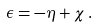<formula> <loc_0><loc_0><loc_500><loc_500>\epsilon = - \eta + \chi \, .</formula> 